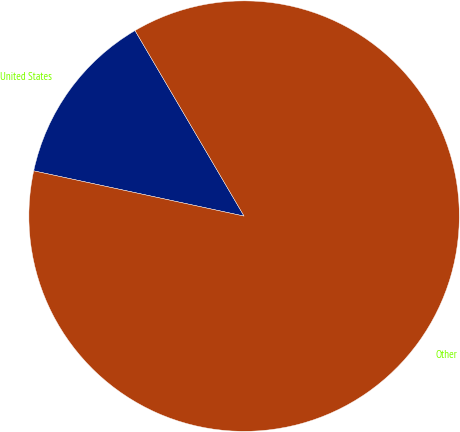Convert chart to OTSL. <chart><loc_0><loc_0><loc_500><loc_500><pie_chart><fcel>United States<fcel>Other<nl><fcel>13.17%<fcel>86.83%<nl></chart> 